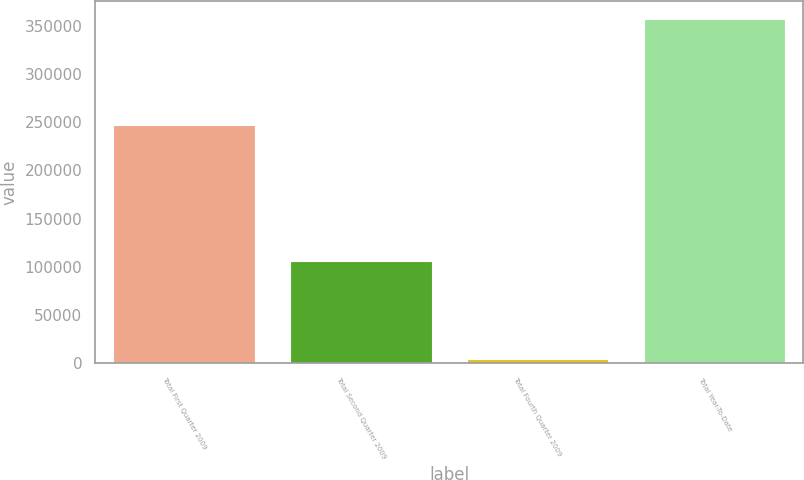Convert chart. <chart><loc_0><loc_0><loc_500><loc_500><bar_chart><fcel>Total First Quarter 2009<fcel>Total Second Quarter 2009<fcel>Total Fourth Quarter 2009<fcel>Total Year-To-Date<nl><fcel>247395<fcel>105731<fcel>4561<fcel>357687<nl></chart> 